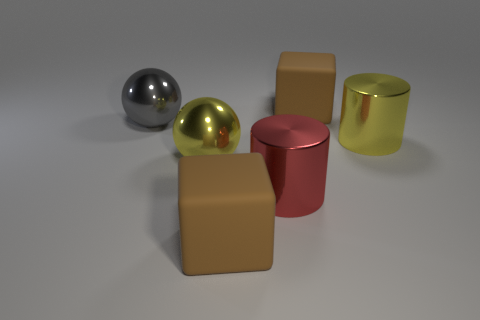Add 3 big yellow shiny cylinders. How many objects exist? 9 Subtract all cubes. How many objects are left? 4 Subtract 0 green blocks. How many objects are left? 6 Subtract all red cylinders. Subtract all metal cylinders. How many objects are left? 3 Add 1 big objects. How many big objects are left? 7 Add 5 small purple matte cubes. How many small purple matte cubes exist? 5 